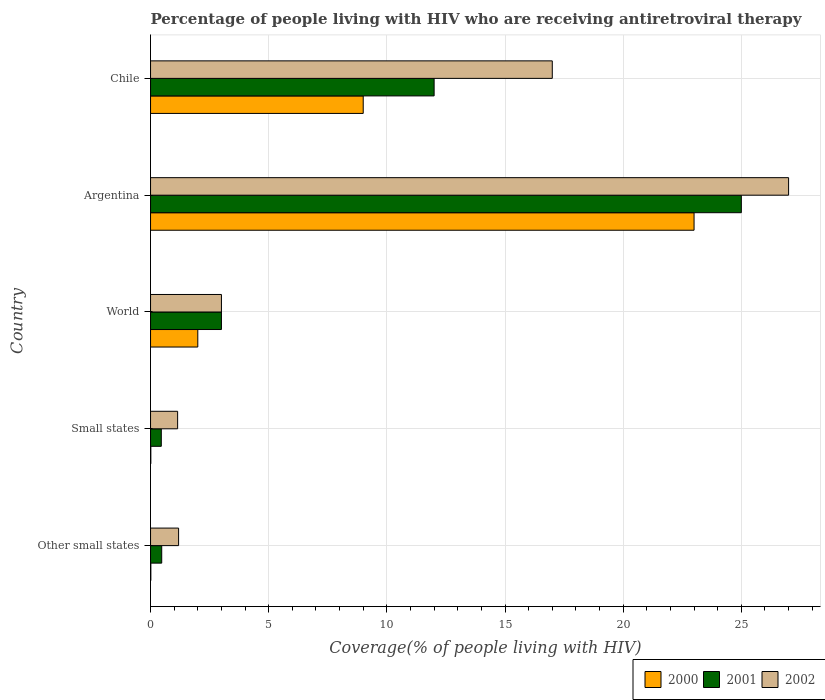How many groups of bars are there?
Your response must be concise. 5. Are the number of bars per tick equal to the number of legend labels?
Your answer should be very brief. Yes. How many bars are there on the 4th tick from the top?
Ensure brevity in your answer.  3. What is the label of the 5th group of bars from the top?
Your response must be concise. Other small states. In how many cases, is the number of bars for a given country not equal to the number of legend labels?
Your response must be concise. 0. What is the percentage of the HIV infected people who are receiving antiretroviral therapy in 2000 in Chile?
Provide a succinct answer. 9. Across all countries, what is the minimum percentage of the HIV infected people who are receiving antiretroviral therapy in 2000?
Provide a succinct answer. 0.01. In which country was the percentage of the HIV infected people who are receiving antiretroviral therapy in 2002 minimum?
Provide a succinct answer. Small states. What is the total percentage of the HIV infected people who are receiving antiretroviral therapy in 2002 in the graph?
Provide a short and direct response. 49.33. What is the difference between the percentage of the HIV infected people who are receiving antiretroviral therapy in 2001 in Other small states and that in World?
Offer a terse response. -2.53. What is the average percentage of the HIV infected people who are receiving antiretroviral therapy in 2000 per country?
Your response must be concise. 6.81. What is the difference between the percentage of the HIV infected people who are receiving antiretroviral therapy in 2000 and percentage of the HIV infected people who are receiving antiretroviral therapy in 2001 in Small states?
Provide a short and direct response. -0.44. In how many countries, is the percentage of the HIV infected people who are receiving antiretroviral therapy in 2001 greater than 3 %?
Offer a very short reply. 2. What is the ratio of the percentage of the HIV infected people who are receiving antiretroviral therapy in 2002 in Argentina to that in Small states?
Make the answer very short. 23.55. What is the difference between the highest and the lowest percentage of the HIV infected people who are receiving antiretroviral therapy in 2000?
Your answer should be very brief. 22.99. In how many countries, is the percentage of the HIV infected people who are receiving antiretroviral therapy in 2001 greater than the average percentage of the HIV infected people who are receiving antiretroviral therapy in 2001 taken over all countries?
Your answer should be compact. 2. What does the 1st bar from the top in Chile represents?
Give a very brief answer. 2002. What does the 2nd bar from the bottom in Other small states represents?
Keep it short and to the point. 2001. How many bars are there?
Your response must be concise. 15. What is the difference between two consecutive major ticks on the X-axis?
Give a very brief answer. 5. Does the graph contain grids?
Give a very brief answer. Yes. How many legend labels are there?
Keep it short and to the point. 3. How are the legend labels stacked?
Keep it short and to the point. Horizontal. What is the title of the graph?
Your answer should be compact. Percentage of people living with HIV who are receiving antiretroviral therapy. What is the label or title of the X-axis?
Ensure brevity in your answer.  Coverage(% of people living with HIV). What is the Coverage(% of people living with HIV) in 2000 in Other small states?
Your answer should be compact. 0.01. What is the Coverage(% of people living with HIV) in 2001 in Other small states?
Your answer should be very brief. 0.47. What is the Coverage(% of people living with HIV) in 2002 in Other small states?
Offer a terse response. 1.19. What is the Coverage(% of people living with HIV) in 2000 in Small states?
Your response must be concise. 0.01. What is the Coverage(% of people living with HIV) of 2001 in Small states?
Offer a terse response. 0.45. What is the Coverage(% of people living with HIV) in 2002 in Small states?
Your response must be concise. 1.15. What is the Coverage(% of people living with HIV) of 2001 in Argentina?
Give a very brief answer. 25. What is the Coverage(% of people living with HIV) of 2002 in Argentina?
Give a very brief answer. 27. What is the Coverage(% of people living with HIV) of 2001 in Chile?
Offer a terse response. 12. What is the Coverage(% of people living with HIV) in 2002 in Chile?
Make the answer very short. 17. Across all countries, what is the maximum Coverage(% of people living with HIV) of 2000?
Keep it short and to the point. 23. Across all countries, what is the maximum Coverage(% of people living with HIV) in 2001?
Offer a very short reply. 25. Across all countries, what is the maximum Coverage(% of people living with HIV) of 2002?
Offer a terse response. 27. Across all countries, what is the minimum Coverage(% of people living with HIV) of 2000?
Your answer should be very brief. 0.01. Across all countries, what is the minimum Coverage(% of people living with HIV) in 2001?
Your answer should be very brief. 0.45. Across all countries, what is the minimum Coverage(% of people living with HIV) of 2002?
Give a very brief answer. 1.15. What is the total Coverage(% of people living with HIV) of 2000 in the graph?
Keep it short and to the point. 34.03. What is the total Coverage(% of people living with HIV) in 2001 in the graph?
Make the answer very short. 40.93. What is the total Coverage(% of people living with HIV) of 2002 in the graph?
Your answer should be compact. 49.33. What is the difference between the Coverage(% of people living with HIV) in 2000 in Other small states and that in Small states?
Your answer should be compact. 0. What is the difference between the Coverage(% of people living with HIV) in 2001 in Other small states and that in Small states?
Provide a succinct answer. 0.02. What is the difference between the Coverage(% of people living with HIV) of 2002 in Other small states and that in Small states?
Provide a succinct answer. 0.04. What is the difference between the Coverage(% of people living with HIV) in 2000 in Other small states and that in World?
Your answer should be compact. -1.99. What is the difference between the Coverage(% of people living with HIV) in 2001 in Other small states and that in World?
Ensure brevity in your answer.  -2.53. What is the difference between the Coverage(% of people living with HIV) of 2002 in Other small states and that in World?
Provide a short and direct response. -1.81. What is the difference between the Coverage(% of people living with HIV) in 2000 in Other small states and that in Argentina?
Ensure brevity in your answer.  -22.99. What is the difference between the Coverage(% of people living with HIV) in 2001 in Other small states and that in Argentina?
Provide a succinct answer. -24.53. What is the difference between the Coverage(% of people living with HIV) in 2002 in Other small states and that in Argentina?
Your response must be concise. -25.81. What is the difference between the Coverage(% of people living with HIV) of 2000 in Other small states and that in Chile?
Give a very brief answer. -8.99. What is the difference between the Coverage(% of people living with HIV) of 2001 in Other small states and that in Chile?
Provide a succinct answer. -11.53. What is the difference between the Coverage(% of people living with HIV) in 2002 in Other small states and that in Chile?
Your response must be concise. -15.81. What is the difference between the Coverage(% of people living with HIV) of 2000 in Small states and that in World?
Offer a very short reply. -1.99. What is the difference between the Coverage(% of people living with HIV) of 2001 in Small states and that in World?
Provide a succinct answer. -2.54. What is the difference between the Coverage(% of people living with HIV) of 2002 in Small states and that in World?
Keep it short and to the point. -1.85. What is the difference between the Coverage(% of people living with HIV) of 2000 in Small states and that in Argentina?
Your answer should be compact. -22.99. What is the difference between the Coverage(% of people living with HIV) of 2001 in Small states and that in Argentina?
Offer a terse response. -24.55. What is the difference between the Coverage(% of people living with HIV) of 2002 in Small states and that in Argentina?
Ensure brevity in your answer.  -25.85. What is the difference between the Coverage(% of people living with HIV) of 2000 in Small states and that in Chile?
Keep it short and to the point. -8.99. What is the difference between the Coverage(% of people living with HIV) of 2001 in Small states and that in Chile?
Offer a terse response. -11.54. What is the difference between the Coverage(% of people living with HIV) in 2002 in Small states and that in Chile?
Your answer should be very brief. -15.85. What is the difference between the Coverage(% of people living with HIV) of 2001 in World and that in Argentina?
Offer a very short reply. -22. What is the difference between the Coverage(% of people living with HIV) of 2002 in World and that in Argentina?
Provide a succinct answer. -24. What is the difference between the Coverage(% of people living with HIV) of 2002 in Argentina and that in Chile?
Your answer should be compact. 10. What is the difference between the Coverage(% of people living with HIV) in 2000 in Other small states and the Coverage(% of people living with HIV) in 2001 in Small states?
Keep it short and to the point. -0.44. What is the difference between the Coverage(% of people living with HIV) in 2000 in Other small states and the Coverage(% of people living with HIV) in 2002 in Small states?
Your answer should be compact. -1.13. What is the difference between the Coverage(% of people living with HIV) in 2001 in Other small states and the Coverage(% of people living with HIV) in 2002 in Small states?
Make the answer very short. -0.67. What is the difference between the Coverage(% of people living with HIV) of 2000 in Other small states and the Coverage(% of people living with HIV) of 2001 in World?
Your response must be concise. -2.99. What is the difference between the Coverage(% of people living with HIV) in 2000 in Other small states and the Coverage(% of people living with HIV) in 2002 in World?
Provide a succinct answer. -2.99. What is the difference between the Coverage(% of people living with HIV) in 2001 in Other small states and the Coverage(% of people living with HIV) in 2002 in World?
Ensure brevity in your answer.  -2.53. What is the difference between the Coverage(% of people living with HIV) of 2000 in Other small states and the Coverage(% of people living with HIV) of 2001 in Argentina?
Keep it short and to the point. -24.99. What is the difference between the Coverage(% of people living with HIV) of 2000 in Other small states and the Coverage(% of people living with HIV) of 2002 in Argentina?
Keep it short and to the point. -26.99. What is the difference between the Coverage(% of people living with HIV) in 2001 in Other small states and the Coverage(% of people living with HIV) in 2002 in Argentina?
Your answer should be compact. -26.53. What is the difference between the Coverage(% of people living with HIV) in 2000 in Other small states and the Coverage(% of people living with HIV) in 2001 in Chile?
Offer a very short reply. -11.99. What is the difference between the Coverage(% of people living with HIV) in 2000 in Other small states and the Coverage(% of people living with HIV) in 2002 in Chile?
Give a very brief answer. -16.99. What is the difference between the Coverage(% of people living with HIV) of 2001 in Other small states and the Coverage(% of people living with HIV) of 2002 in Chile?
Provide a short and direct response. -16.53. What is the difference between the Coverage(% of people living with HIV) in 2000 in Small states and the Coverage(% of people living with HIV) in 2001 in World?
Provide a short and direct response. -2.99. What is the difference between the Coverage(% of people living with HIV) of 2000 in Small states and the Coverage(% of people living with HIV) of 2002 in World?
Your response must be concise. -2.99. What is the difference between the Coverage(% of people living with HIV) of 2001 in Small states and the Coverage(% of people living with HIV) of 2002 in World?
Your answer should be very brief. -2.54. What is the difference between the Coverage(% of people living with HIV) of 2000 in Small states and the Coverage(% of people living with HIV) of 2001 in Argentina?
Your answer should be very brief. -24.99. What is the difference between the Coverage(% of people living with HIV) of 2000 in Small states and the Coverage(% of people living with HIV) of 2002 in Argentina?
Your response must be concise. -26.99. What is the difference between the Coverage(% of people living with HIV) in 2001 in Small states and the Coverage(% of people living with HIV) in 2002 in Argentina?
Your answer should be very brief. -26.55. What is the difference between the Coverage(% of people living with HIV) in 2000 in Small states and the Coverage(% of people living with HIV) in 2001 in Chile?
Offer a very short reply. -11.99. What is the difference between the Coverage(% of people living with HIV) of 2000 in Small states and the Coverage(% of people living with HIV) of 2002 in Chile?
Offer a terse response. -16.99. What is the difference between the Coverage(% of people living with HIV) of 2001 in Small states and the Coverage(% of people living with HIV) of 2002 in Chile?
Your answer should be very brief. -16.55. What is the difference between the Coverage(% of people living with HIV) of 2000 in World and the Coverage(% of people living with HIV) of 2002 in Argentina?
Give a very brief answer. -25. What is the difference between the Coverage(% of people living with HIV) of 2001 in World and the Coverage(% of people living with HIV) of 2002 in Argentina?
Provide a succinct answer. -24. What is the difference between the Coverage(% of people living with HIV) in 2000 in World and the Coverage(% of people living with HIV) in 2001 in Chile?
Provide a succinct answer. -10. What is the difference between the Coverage(% of people living with HIV) in 2000 in World and the Coverage(% of people living with HIV) in 2002 in Chile?
Offer a very short reply. -15. What is the difference between the Coverage(% of people living with HIV) of 2000 in Argentina and the Coverage(% of people living with HIV) of 2001 in Chile?
Make the answer very short. 11. What is the difference between the Coverage(% of people living with HIV) of 2000 in Argentina and the Coverage(% of people living with HIV) of 2002 in Chile?
Offer a terse response. 6. What is the average Coverage(% of people living with HIV) in 2000 per country?
Your answer should be compact. 6.81. What is the average Coverage(% of people living with HIV) in 2001 per country?
Your response must be concise. 8.19. What is the average Coverage(% of people living with HIV) of 2002 per country?
Your response must be concise. 9.87. What is the difference between the Coverage(% of people living with HIV) in 2000 and Coverage(% of people living with HIV) in 2001 in Other small states?
Your answer should be compact. -0.46. What is the difference between the Coverage(% of people living with HIV) of 2000 and Coverage(% of people living with HIV) of 2002 in Other small states?
Make the answer very short. -1.17. What is the difference between the Coverage(% of people living with HIV) of 2001 and Coverage(% of people living with HIV) of 2002 in Other small states?
Make the answer very short. -0.71. What is the difference between the Coverage(% of people living with HIV) of 2000 and Coverage(% of people living with HIV) of 2001 in Small states?
Ensure brevity in your answer.  -0.44. What is the difference between the Coverage(% of people living with HIV) in 2000 and Coverage(% of people living with HIV) in 2002 in Small states?
Make the answer very short. -1.13. What is the difference between the Coverage(% of people living with HIV) of 2001 and Coverage(% of people living with HIV) of 2002 in Small states?
Offer a very short reply. -0.69. What is the difference between the Coverage(% of people living with HIV) in 2000 and Coverage(% of people living with HIV) in 2001 in World?
Provide a short and direct response. -1. What is the difference between the Coverage(% of people living with HIV) in 2001 and Coverage(% of people living with HIV) in 2002 in World?
Make the answer very short. 0. What is the difference between the Coverage(% of people living with HIV) of 2000 and Coverage(% of people living with HIV) of 2001 in Argentina?
Provide a succinct answer. -2. What is the difference between the Coverage(% of people living with HIV) in 2001 and Coverage(% of people living with HIV) in 2002 in Argentina?
Ensure brevity in your answer.  -2. What is the difference between the Coverage(% of people living with HIV) of 2000 and Coverage(% of people living with HIV) of 2001 in Chile?
Your answer should be very brief. -3. What is the difference between the Coverage(% of people living with HIV) of 2000 and Coverage(% of people living with HIV) of 2002 in Chile?
Offer a terse response. -8. What is the difference between the Coverage(% of people living with HIV) of 2001 and Coverage(% of people living with HIV) of 2002 in Chile?
Provide a succinct answer. -5. What is the ratio of the Coverage(% of people living with HIV) in 2000 in Other small states to that in Small states?
Offer a very short reply. 1.05. What is the ratio of the Coverage(% of people living with HIV) of 2001 in Other small states to that in Small states?
Give a very brief answer. 1.04. What is the ratio of the Coverage(% of people living with HIV) in 2002 in Other small states to that in Small states?
Your answer should be compact. 1.04. What is the ratio of the Coverage(% of people living with HIV) in 2000 in Other small states to that in World?
Provide a short and direct response. 0.01. What is the ratio of the Coverage(% of people living with HIV) of 2001 in Other small states to that in World?
Provide a short and direct response. 0.16. What is the ratio of the Coverage(% of people living with HIV) in 2002 in Other small states to that in World?
Offer a terse response. 0.4. What is the ratio of the Coverage(% of people living with HIV) in 2000 in Other small states to that in Argentina?
Provide a succinct answer. 0. What is the ratio of the Coverage(% of people living with HIV) in 2001 in Other small states to that in Argentina?
Your answer should be very brief. 0.02. What is the ratio of the Coverage(% of people living with HIV) of 2002 in Other small states to that in Argentina?
Offer a terse response. 0.04. What is the ratio of the Coverage(% of people living with HIV) in 2000 in Other small states to that in Chile?
Your answer should be very brief. 0. What is the ratio of the Coverage(% of people living with HIV) of 2001 in Other small states to that in Chile?
Your response must be concise. 0.04. What is the ratio of the Coverage(% of people living with HIV) of 2002 in Other small states to that in Chile?
Ensure brevity in your answer.  0.07. What is the ratio of the Coverage(% of people living with HIV) in 2000 in Small states to that in World?
Your answer should be very brief. 0.01. What is the ratio of the Coverage(% of people living with HIV) of 2001 in Small states to that in World?
Provide a succinct answer. 0.15. What is the ratio of the Coverage(% of people living with HIV) of 2002 in Small states to that in World?
Provide a succinct answer. 0.38. What is the ratio of the Coverage(% of people living with HIV) in 2001 in Small states to that in Argentina?
Offer a terse response. 0.02. What is the ratio of the Coverage(% of people living with HIV) of 2002 in Small states to that in Argentina?
Your answer should be compact. 0.04. What is the ratio of the Coverage(% of people living with HIV) of 2000 in Small states to that in Chile?
Provide a succinct answer. 0. What is the ratio of the Coverage(% of people living with HIV) in 2001 in Small states to that in Chile?
Provide a succinct answer. 0.04. What is the ratio of the Coverage(% of people living with HIV) of 2002 in Small states to that in Chile?
Make the answer very short. 0.07. What is the ratio of the Coverage(% of people living with HIV) of 2000 in World to that in Argentina?
Your response must be concise. 0.09. What is the ratio of the Coverage(% of people living with HIV) in 2001 in World to that in Argentina?
Your answer should be compact. 0.12. What is the ratio of the Coverage(% of people living with HIV) of 2000 in World to that in Chile?
Provide a succinct answer. 0.22. What is the ratio of the Coverage(% of people living with HIV) in 2002 in World to that in Chile?
Ensure brevity in your answer.  0.18. What is the ratio of the Coverage(% of people living with HIV) in 2000 in Argentina to that in Chile?
Your answer should be very brief. 2.56. What is the ratio of the Coverage(% of people living with HIV) in 2001 in Argentina to that in Chile?
Offer a terse response. 2.08. What is the ratio of the Coverage(% of people living with HIV) in 2002 in Argentina to that in Chile?
Make the answer very short. 1.59. What is the difference between the highest and the second highest Coverage(% of people living with HIV) of 2000?
Offer a very short reply. 14. What is the difference between the highest and the lowest Coverage(% of people living with HIV) of 2000?
Make the answer very short. 22.99. What is the difference between the highest and the lowest Coverage(% of people living with HIV) in 2001?
Keep it short and to the point. 24.55. What is the difference between the highest and the lowest Coverage(% of people living with HIV) of 2002?
Your response must be concise. 25.85. 